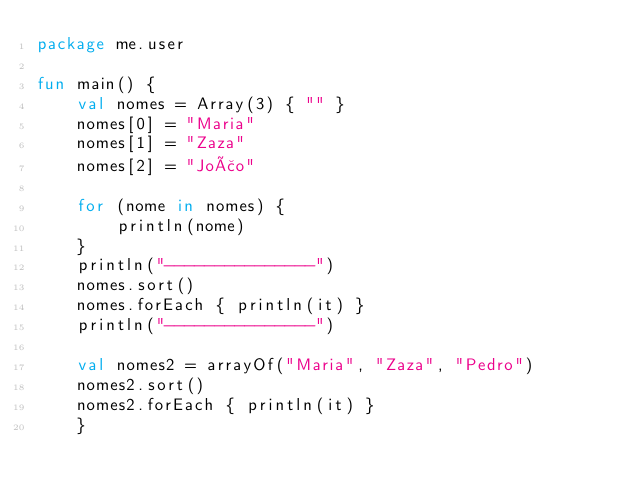<code> <loc_0><loc_0><loc_500><loc_500><_Kotlin_>package me.user

fun main() {
    val nomes = Array(3) { "" }
    nomes[0] = "Maria"
    nomes[1] = "Zaza"
    nomes[2] = "João"

    for (nome in nomes) {
        println(nome)
    }
    println("---------------")
    nomes.sort()
    nomes.forEach { println(it) }
    println("---------------")

    val nomes2 = arrayOf("Maria", "Zaza", "Pedro")
    nomes2.sort()
    nomes2.forEach { println(it) }
    }</code> 